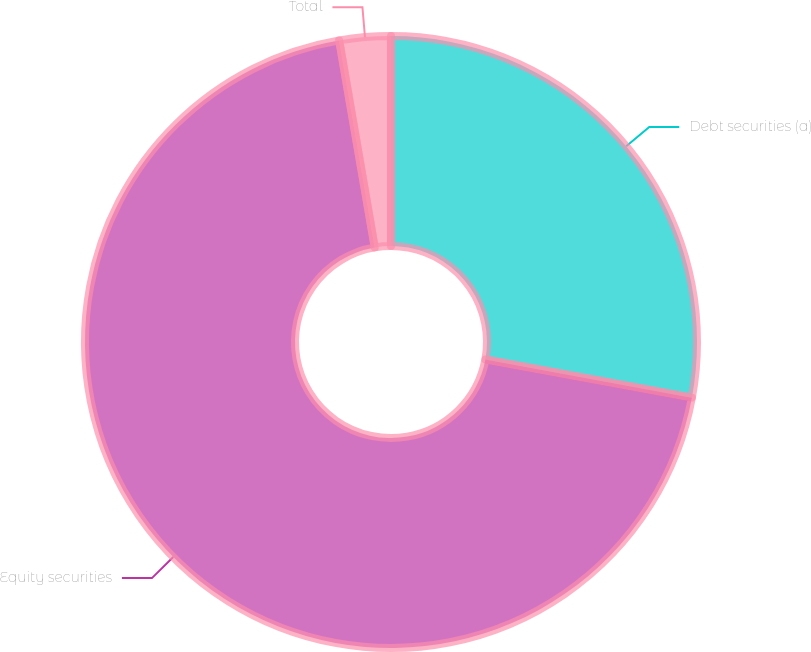<chart> <loc_0><loc_0><loc_500><loc_500><pie_chart><fcel>Debt securities (a)<fcel>Equity securities<fcel>Total<nl><fcel>27.91%<fcel>69.38%<fcel>2.71%<nl></chart> 